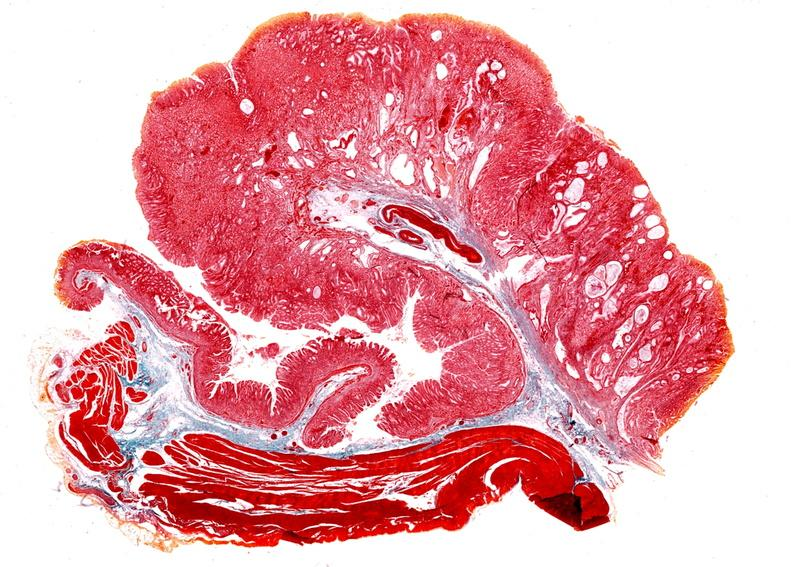s gastrointestinal present?
Answer the question using a single word or phrase. Yes 